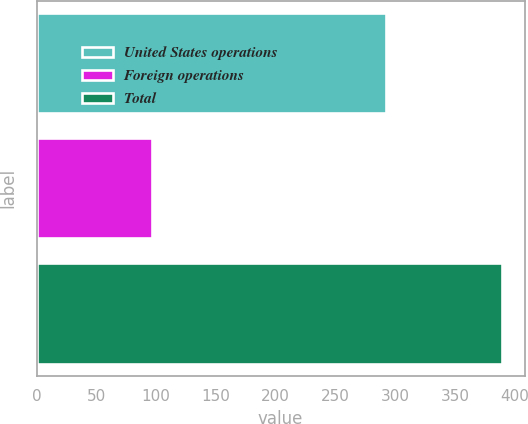Convert chart. <chart><loc_0><loc_0><loc_500><loc_500><bar_chart><fcel>United States operations<fcel>Foreign operations<fcel>Total<nl><fcel>292<fcel>96.9<fcel>388.9<nl></chart> 